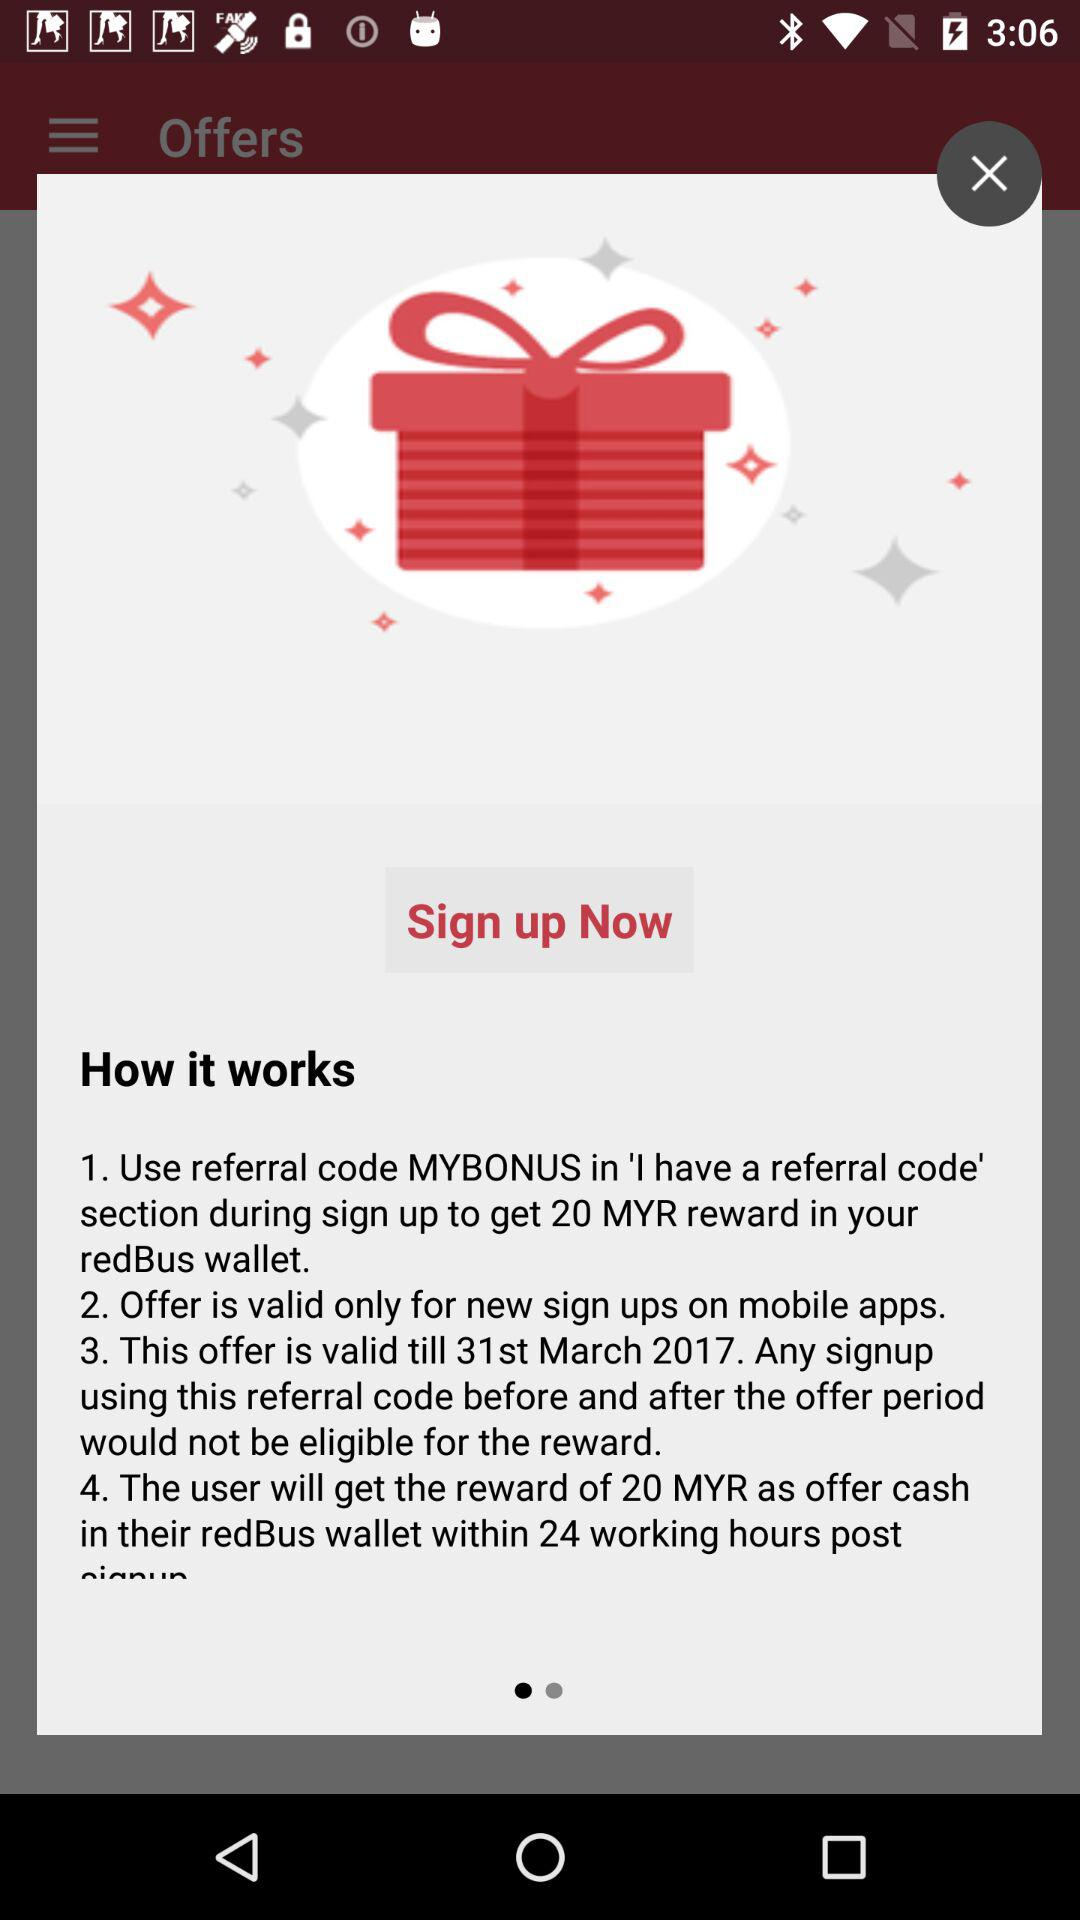How much will the user be rewarded? The user will be rewarded 20 MYR. 